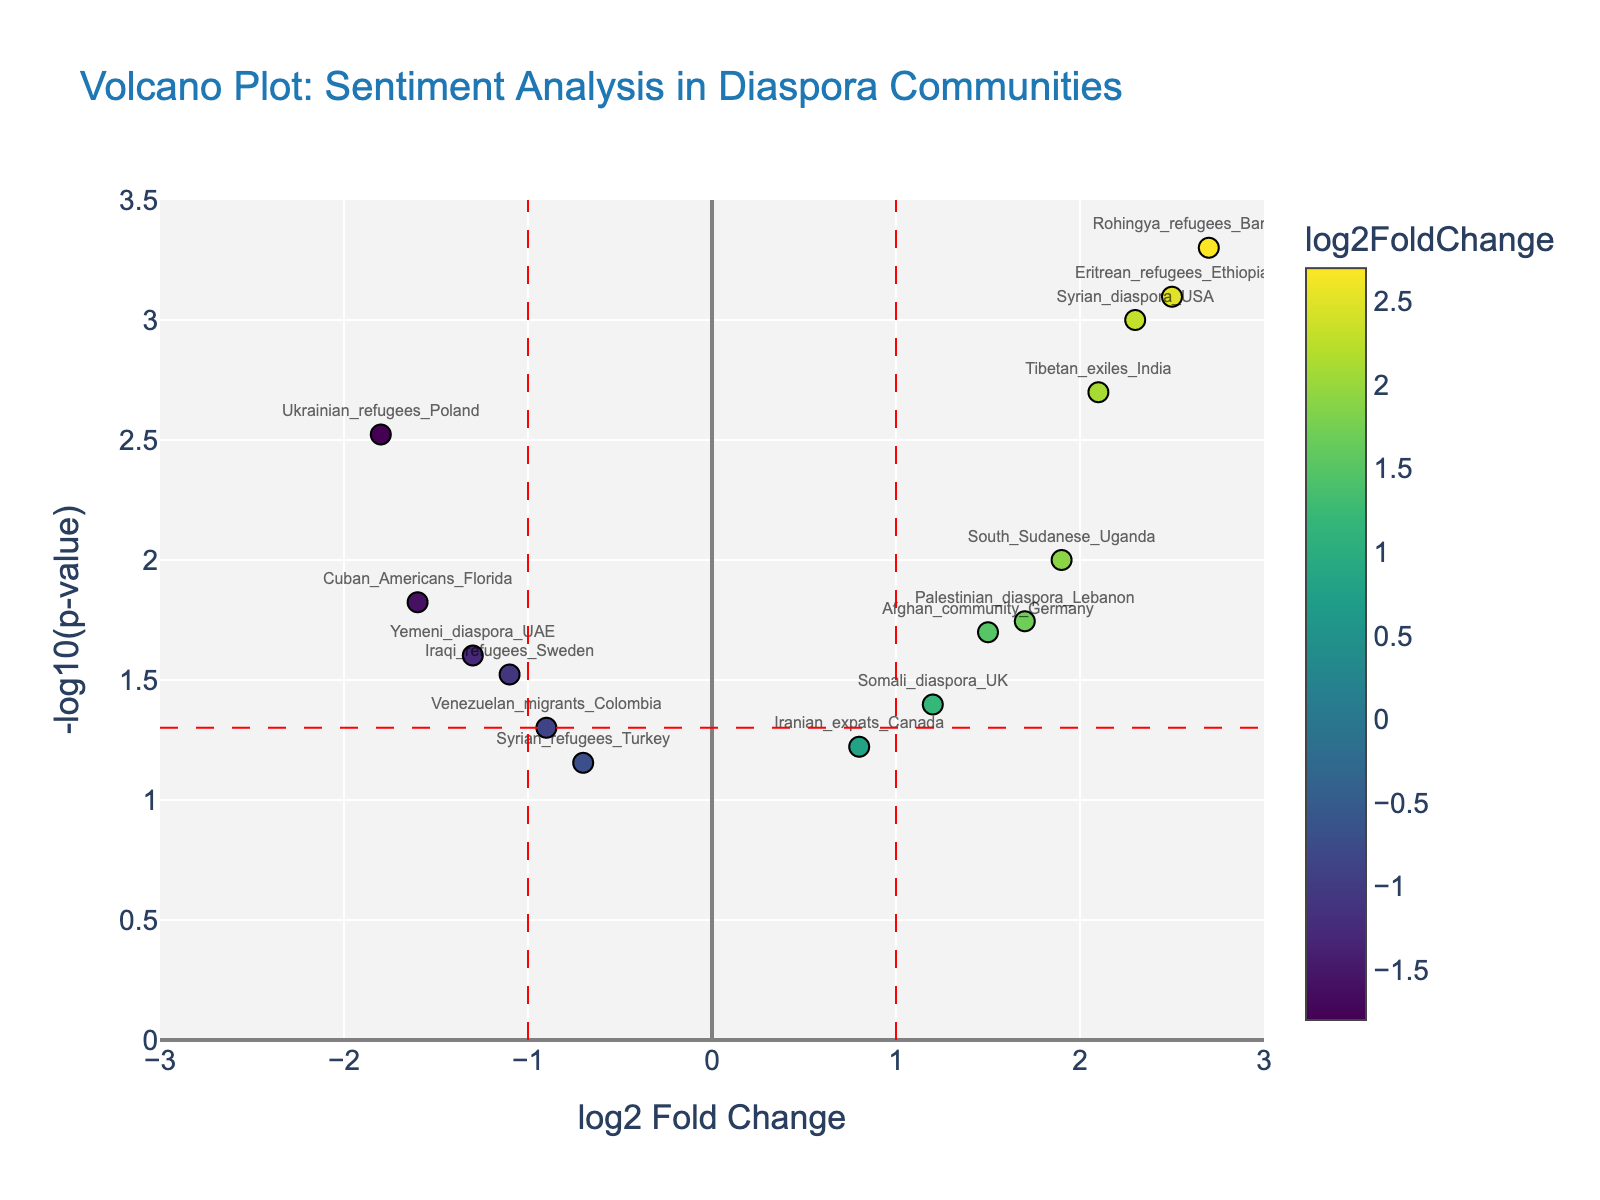Who has the highest log2 fold change? Look at the x-axis and identify the data point farthest to the right. This indicates the highest log2 fold change. The Syrian_diaspora_USA data point is the farthest right.
Answer: Syrian_diaspora_USA Which group shows the most significant sentiment change towards their host country? The significance level can be determined by the y-axis value (-log10(p-value)). The Rohingya_refugees_Bangladesh data point is the highest on the y-axis, indicating the most significant p-value (lowest p-value).
Answer: Rohingya_refugees_Bangladesh How many data points have a log2 fold change greater than 1? Count the number of data points to the right of the x-axis value of 1. The relevant points are Syrian_diaspora_USA, Syrian_diaspora_Germany, South_Sudanese_Uganda, Iranian_expats_Canada, and Syrian_diaspora_UK.
Answer: 5 How many groups exhibit negative sentiment towards their homeland? Look for data points with log2 fold change below zero on the x-axis.  The corresponding points are Ukrainian_refugees_Poland, Venezuelan_migrants_Colombia, Iraqi_refugees_Sweden, Syrian_refugees_Turkey, Yemeni_diaspora_UAE, and Cuban_Americans_Florida.
Answer: 6 Which group shows the least significant sentiment change towards their homeland? The least significant change can be determined by the lowest y-axis value (-log10(p-value)). The Syrian_refugees_Turkey data point is the lowest on the y-axis, indicating the highest p-value.
Answer: Syrian_refugees_Turkey 